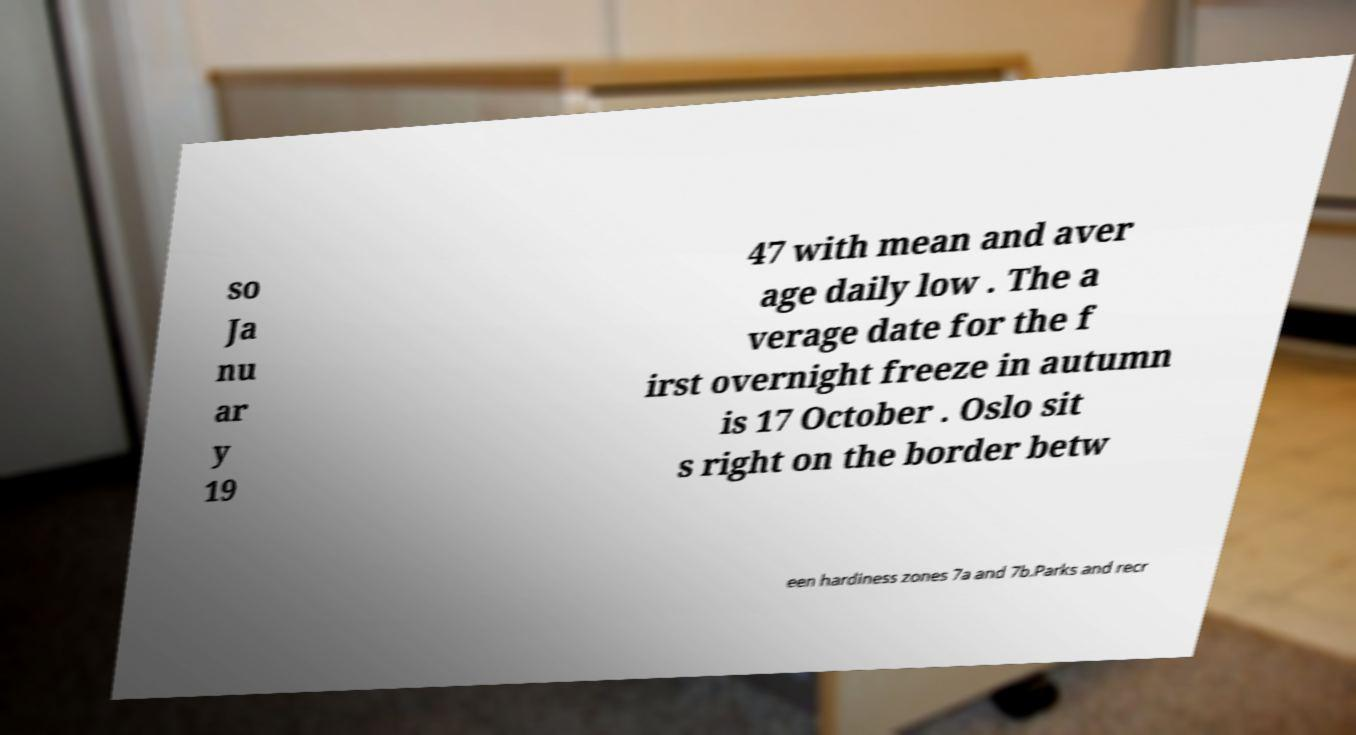Could you assist in decoding the text presented in this image and type it out clearly? so Ja nu ar y 19 47 with mean and aver age daily low . The a verage date for the f irst overnight freeze in autumn is 17 October . Oslo sit s right on the border betw een hardiness zones 7a and 7b.Parks and recr 